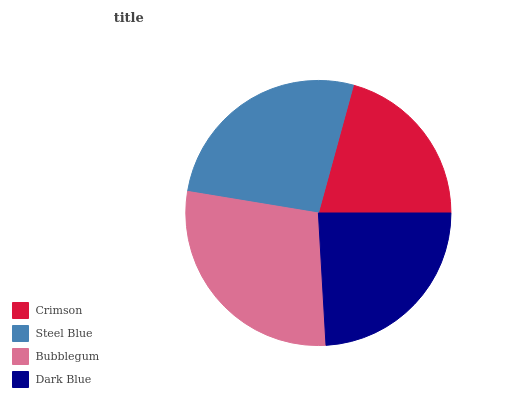Is Crimson the minimum?
Answer yes or no. Yes. Is Bubblegum the maximum?
Answer yes or no. Yes. Is Steel Blue the minimum?
Answer yes or no. No. Is Steel Blue the maximum?
Answer yes or no. No. Is Steel Blue greater than Crimson?
Answer yes or no. Yes. Is Crimson less than Steel Blue?
Answer yes or no. Yes. Is Crimson greater than Steel Blue?
Answer yes or no. No. Is Steel Blue less than Crimson?
Answer yes or no. No. Is Steel Blue the high median?
Answer yes or no. Yes. Is Dark Blue the low median?
Answer yes or no. Yes. Is Bubblegum the high median?
Answer yes or no. No. Is Bubblegum the low median?
Answer yes or no. No. 